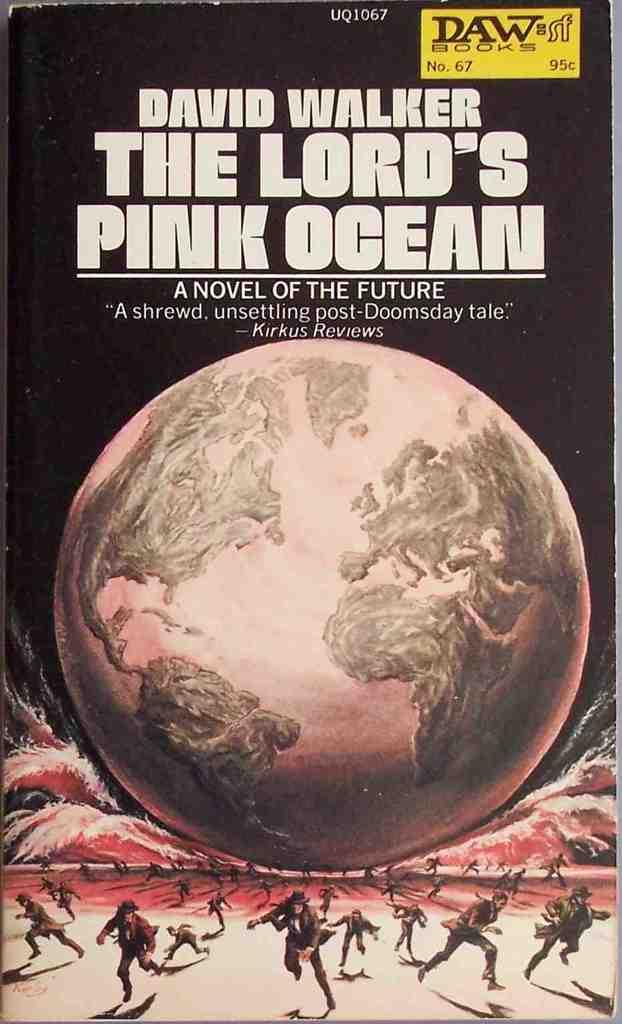Provide a one-sentence caption for the provided image. The cover of the novel "The Lord's Pink Ocean" that shows a pink globe seeming to crush people who are running away. 